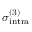Convert formula to latex. <formula><loc_0><loc_0><loc_500><loc_500>\sigma _ { i n t r a } ^ { ( 3 ) }</formula> 